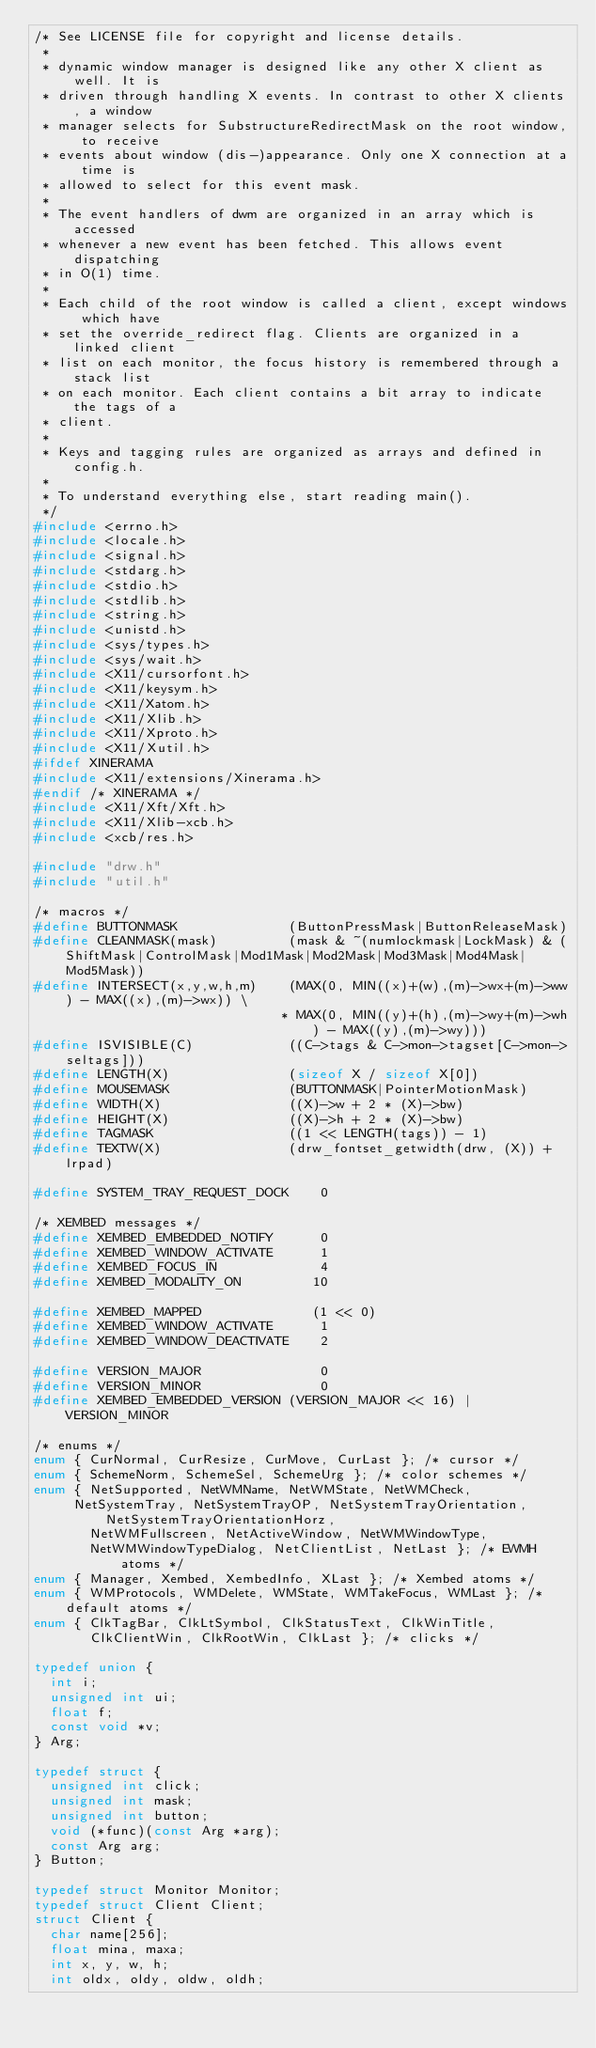Convert code to text. <code><loc_0><loc_0><loc_500><loc_500><_C_>/* See LICENSE file for copyright and license details.
 *
 * dynamic window manager is designed like any other X client as well. It is
 * driven through handling X events. In contrast to other X clients, a window
 * manager selects for SubstructureRedirectMask on the root window, to receive
 * events about window (dis-)appearance. Only one X connection at a time is
 * allowed to select for this event mask.
 *
 * The event handlers of dwm are organized in an array which is accessed
 * whenever a new event has been fetched. This allows event dispatching
 * in O(1) time.
 *
 * Each child of the root window is called a client, except windows which have
 * set the override_redirect flag. Clients are organized in a linked client
 * list on each monitor, the focus history is remembered through a stack list
 * on each monitor. Each client contains a bit array to indicate the tags of a
 * client.
 *
 * Keys and tagging rules are organized as arrays and defined in config.h.
 *
 * To understand everything else, start reading main().
 */
#include <errno.h>
#include <locale.h>
#include <signal.h>
#include <stdarg.h>
#include <stdio.h>
#include <stdlib.h>
#include <string.h>
#include <unistd.h>
#include <sys/types.h>
#include <sys/wait.h>
#include <X11/cursorfont.h>
#include <X11/keysym.h>
#include <X11/Xatom.h>
#include <X11/Xlib.h>
#include <X11/Xproto.h>
#include <X11/Xutil.h>
#ifdef XINERAMA
#include <X11/extensions/Xinerama.h>
#endif /* XINERAMA */
#include <X11/Xft/Xft.h>
#include <X11/Xlib-xcb.h>
#include <xcb/res.h>

#include "drw.h"
#include "util.h"

/* macros */
#define BUTTONMASK              (ButtonPressMask|ButtonReleaseMask)
#define CLEANMASK(mask)         (mask & ~(numlockmask|LockMask) & (ShiftMask|ControlMask|Mod1Mask|Mod2Mask|Mod3Mask|Mod4Mask|Mod5Mask))
#define INTERSECT(x,y,w,h,m)    (MAX(0, MIN((x)+(w),(m)->wx+(m)->ww) - MAX((x),(m)->wx)) \
                               * MAX(0, MIN((y)+(h),(m)->wy+(m)->wh) - MAX((y),(m)->wy)))
#define ISVISIBLE(C)            ((C->tags & C->mon->tagset[C->mon->seltags]))
#define LENGTH(X)               (sizeof X / sizeof X[0])
#define MOUSEMASK               (BUTTONMASK|PointerMotionMask)
#define WIDTH(X)                ((X)->w + 2 * (X)->bw)
#define HEIGHT(X)               ((X)->h + 2 * (X)->bw)
#define TAGMASK                 ((1 << LENGTH(tags)) - 1)
#define TEXTW(X)                (drw_fontset_getwidth(drw, (X)) + lrpad)

#define SYSTEM_TRAY_REQUEST_DOCK    0

/* XEMBED messages */
#define XEMBED_EMBEDDED_NOTIFY      0
#define XEMBED_WINDOW_ACTIVATE      1
#define XEMBED_FOCUS_IN             4
#define XEMBED_MODALITY_ON         10

#define XEMBED_MAPPED              (1 << 0)
#define XEMBED_WINDOW_ACTIVATE      1
#define XEMBED_WINDOW_DEACTIVATE    2

#define VERSION_MAJOR               0
#define VERSION_MINOR               0
#define XEMBED_EMBEDDED_VERSION (VERSION_MAJOR << 16) | VERSION_MINOR

/* enums */
enum { CurNormal, CurResize, CurMove, CurLast }; /* cursor */
enum { SchemeNorm, SchemeSel, SchemeUrg }; /* color schemes */
enum { NetSupported, NetWMName, NetWMState, NetWMCheck,
	   NetSystemTray, NetSystemTrayOP, NetSystemTrayOrientation, NetSystemTrayOrientationHorz,
       NetWMFullscreen, NetActiveWindow, NetWMWindowType,
       NetWMWindowTypeDialog, NetClientList, NetLast }; /* EWMH atoms */
enum { Manager, Xembed, XembedInfo, XLast }; /* Xembed atoms */
enum { WMProtocols, WMDelete, WMState, WMTakeFocus, WMLast }; /* default atoms */
enum { ClkTagBar, ClkLtSymbol, ClkStatusText, ClkWinTitle,
       ClkClientWin, ClkRootWin, ClkLast }; /* clicks */

typedef union {
	int i;
	unsigned int ui;
	float f;
	const void *v;
} Arg;

typedef struct {
	unsigned int click;
	unsigned int mask;
	unsigned int button;
	void (*func)(const Arg *arg);
	const Arg arg;
} Button;

typedef struct Monitor Monitor;
typedef struct Client Client;
struct Client {
	char name[256];
	float mina, maxa;
	int x, y, w, h;
	int oldx, oldy, oldw, oldh;</code> 